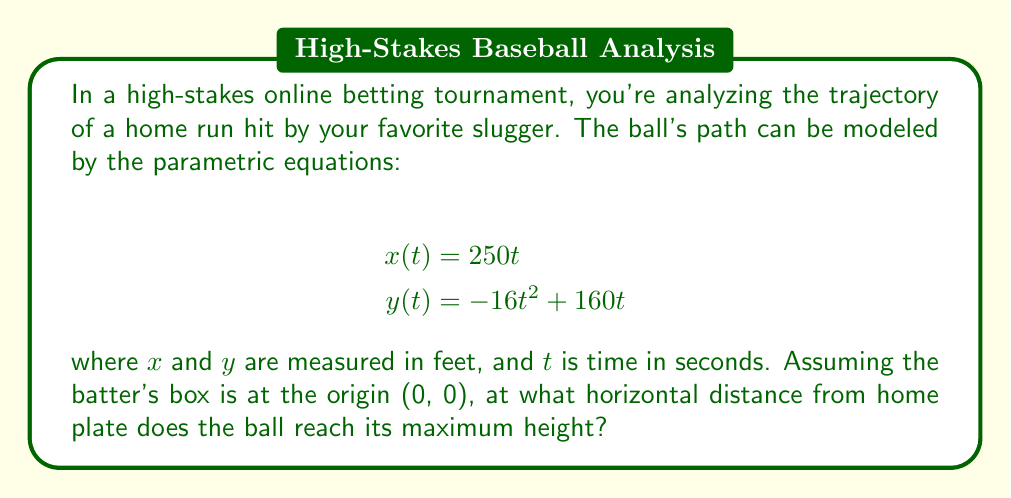Solve this math problem. To solve this problem, we need to follow these steps:

1) First, we need to find when the ball reaches its maximum height. This occurs when the vertical velocity is zero.

2) The vertical velocity is given by the derivative of $y(t)$ with respect to $t$:

   $$\frac{dy}{dt} = -32t + 160$$

3) Set this equal to zero and solve for $t$:

   $$-32t + 160 = 0$$
   $$-32t = -160$$
   $$t = 5$$

4) Now that we know the time at which the ball reaches its maximum height, we can plug this value of $t$ into the equation for $x(t)$ to find the horizontal distance:

   $$x(5) = 250(5) = 1250$$

5) Therefore, the ball reaches its maximum height when it's 1250 feet from home plate.

This analysis could be crucial for betting on whether the ball will clear the outfield fence, which is typically around 400 feet from home plate in most major league stadiums.
Answer: The ball reaches its maximum height at a horizontal distance of 1250 feet from home plate. 